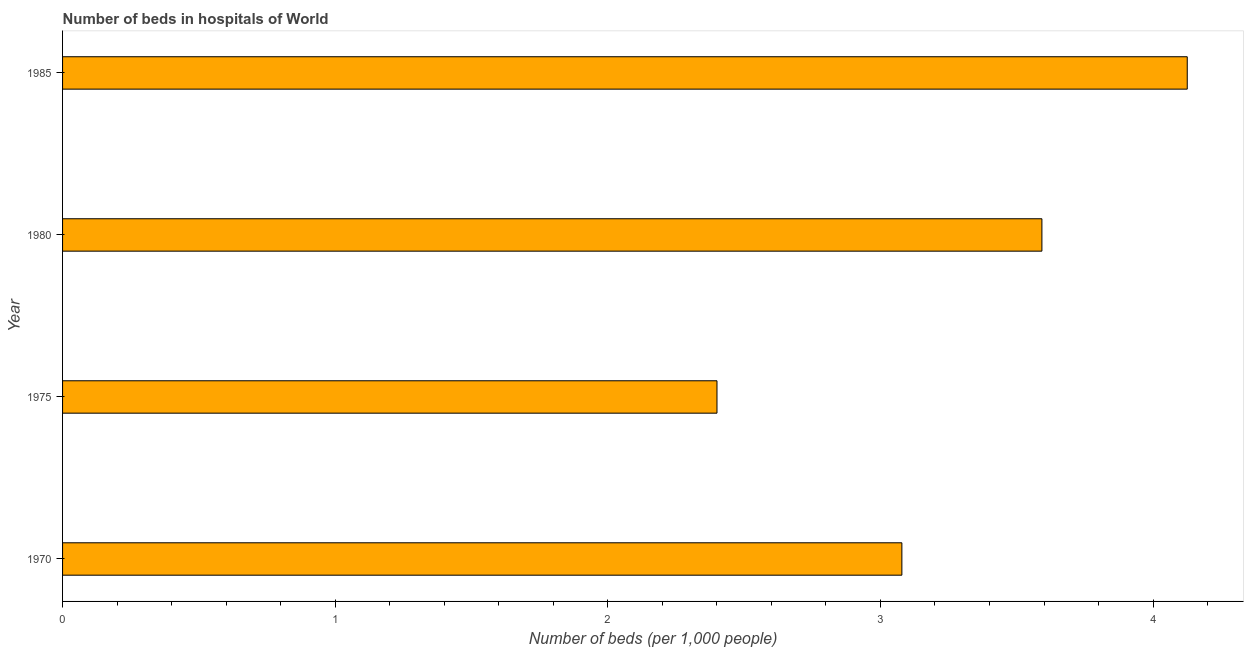Does the graph contain grids?
Provide a succinct answer. No. What is the title of the graph?
Make the answer very short. Number of beds in hospitals of World. What is the label or title of the X-axis?
Your answer should be very brief. Number of beds (per 1,0 people). What is the label or title of the Y-axis?
Your response must be concise. Year. What is the number of hospital beds in 1970?
Provide a short and direct response. 3.08. Across all years, what is the maximum number of hospital beds?
Your response must be concise. 4.13. Across all years, what is the minimum number of hospital beds?
Offer a very short reply. 2.4. In which year was the number of hospital beds maximum?
Offer a very short reply. 1985. In which year was the number of hospital beds minimum?
Your answer should be very brief. 1975. What is the sum of the number of hospital beds?
Make the answer very short. 13.2. What is the difference between the number of hospital beds in 1970 and 1975?
Your answer should be very brief. 0.68. What is the average number of hospital beds per year?
Offer a very short reply. 3.3. What is the median number of hospital beds?
Ensure brevity in your answer.  3.34. What is the ratio of the number of hospital beds in 1975 to that in 1985?
Make the answer very short. 0.58. Is the number of hospital beds in 1970 less than that in 1980?
Give a very brief answer. Yes. What is the difference between the highest and the second highest number of hospital beds?
Your response must be concise. 0.53. What is the difference between the highest and the lowest number of hospital beds?
Make the answer very short. 1.73. What is the difference between two consecutive major ticks on the X-axis?
Your answer should be very brief. 1. What is the Number of beds (per 1,000 people) of 1970?
Keep it short and to the point. 3.08. What is the Number of beds (per 1,000 people) in 1975?
Your answer should be very brief. 2.4. What is the Number of beds (per 1,000 people) in 1980?
Provide a succinct answer. 3.59. What is the Number of beds (per 1,000 people) in 1985?
Your response must be concise. 4.13. What is the difference between the Number of beds (per 1,000 people) in 1970 and 1975?
Ensure brevity in your answer.  0.68. What is the difference between the Number of beds (per 1,000 people) in 1970 and 1980?
Your response must be concise. -0.51. What is the difference between the Number of beds (per 1,000 people) in 1970 and 1985?
Offer a terse response. -1.05. What is the difference between the Number of beds (per 1,000 people) in 1975 and 1980?
Keep it short and to the point. -1.19. What is the difference between the Number of beds (per 1,000 people) in 1975 and 1985?
Your answer should be very brief. -1.73. What is the difference between the Number of beds (per 1,000 people) in 1980 and 1985?
Provide a short and direct response. -0.53. What is the ratio of the Number of beds (per 1,000 people) in 1970 to that in 1975?
Your response must be concise. 1.28. What is the ratio of the Number of beds (per 1,000 people) in 1970 to that in 1980?
Your answer should be very brief. 0.86. What is the ratio of the Number of beds (per 1,000 people) in 1970 to that in 1985?
Provide a short and direct response. 0.75. What is the ratio of the Number of beds (per 1,000 people) in 1975 to that in 1980?
Provide a short and direct response. 0.67. What is the ratio of the Number of beds (per 1,000 people) in 1975 to that in 1985?
Your answer should be compact. 0.58. What is the ratio of the Number of beds (per 1,000 people) in 1980 to that in 1985?
Keep it short and to the point. 0.87. 